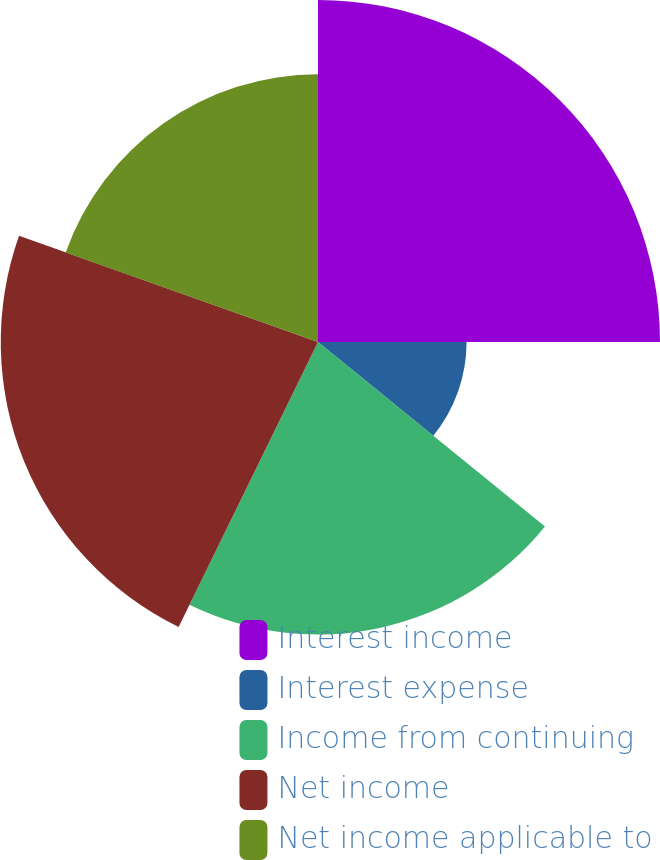<chart> <loc_0><loc_0><loc_500><loc_500><pie_chart><fcel>Interest income<fcel>Interest expense<fcel>Income from continuing<fcel>Net income<fcel>Net income applicable to<nl><fcel>25.0%<fcel>10.86%<fcel>21.38%<fcel>23.19%<fcel>19.57%<nl></chart> 